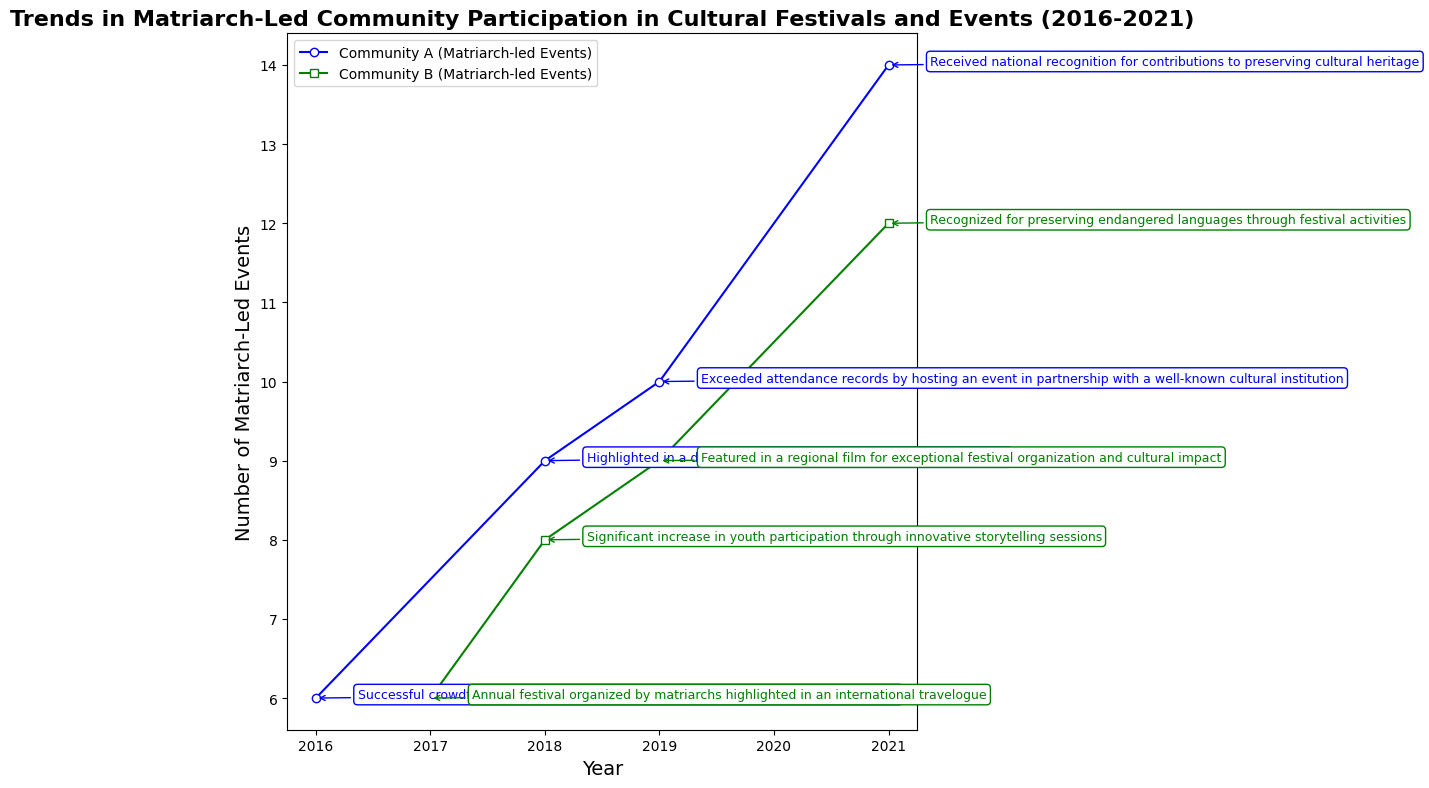What year did Community A receive national recognition for contributions to preserving cultural heritage? Look for the year associated with Community A's success story of receiving national recognition.
Answer: 2021 How many matriarch-led events did Community B have in 2017? Find the year 2017 in the data and check the value for matriarch-led events for Community B.
Answer: 6 Between Community A and Community B, which had more matriarch-led events in 2019? Compare the number of matriarch-led events for both communities in 2019.
Answer: Community A By how many events did matriarch-led events increase in Community A from 2016 to 2021? Subtract the number of matriarch-led events in 2016 from the number in 2021 for Community A.
Answer: 8 What is the combined total of matriarch-led events for both communities in 2018? Sum the number of matriarch-led events for Community A and Community B in 2018.
Answer: 17 During which event did Community B receive recognition for preserving endangered languages? Identify the success story for Community B that mentions preserving endangered languages and note the associated year.
Answer: 2021 Which community had a significant increase in youth participation in 2018? Look for the success story mentioning an increase in youth participation and identify the community.
Answer: Community B What is the average number of matriarch-led events for Community A from 2016 to 2021? Add the number of matriarch-led events for Community A across the years and divide by the number of years (2016, 2018, 2019, 2021). Calculation: (6 + 9 + 10 + 14) / 4 = 39 / 4.
Answer: 9.75 Which year had the highest combined total of matriarch-led events for both communities? Add the matriarch-led events for both communities for each year and identify the highest total. Calculation: 2016: 6+0=6, 2017: 0+6=6, 2018: 9+8=17, 2019: 10+9=19, 2021: 14+12=26.
Answer: 2021 How many matriarch-led events did Community B increase from 2017 to 2021? Subtract the number of matriarch-led events in 2017 from the number in 2021 for Community B.
Answer: 6 